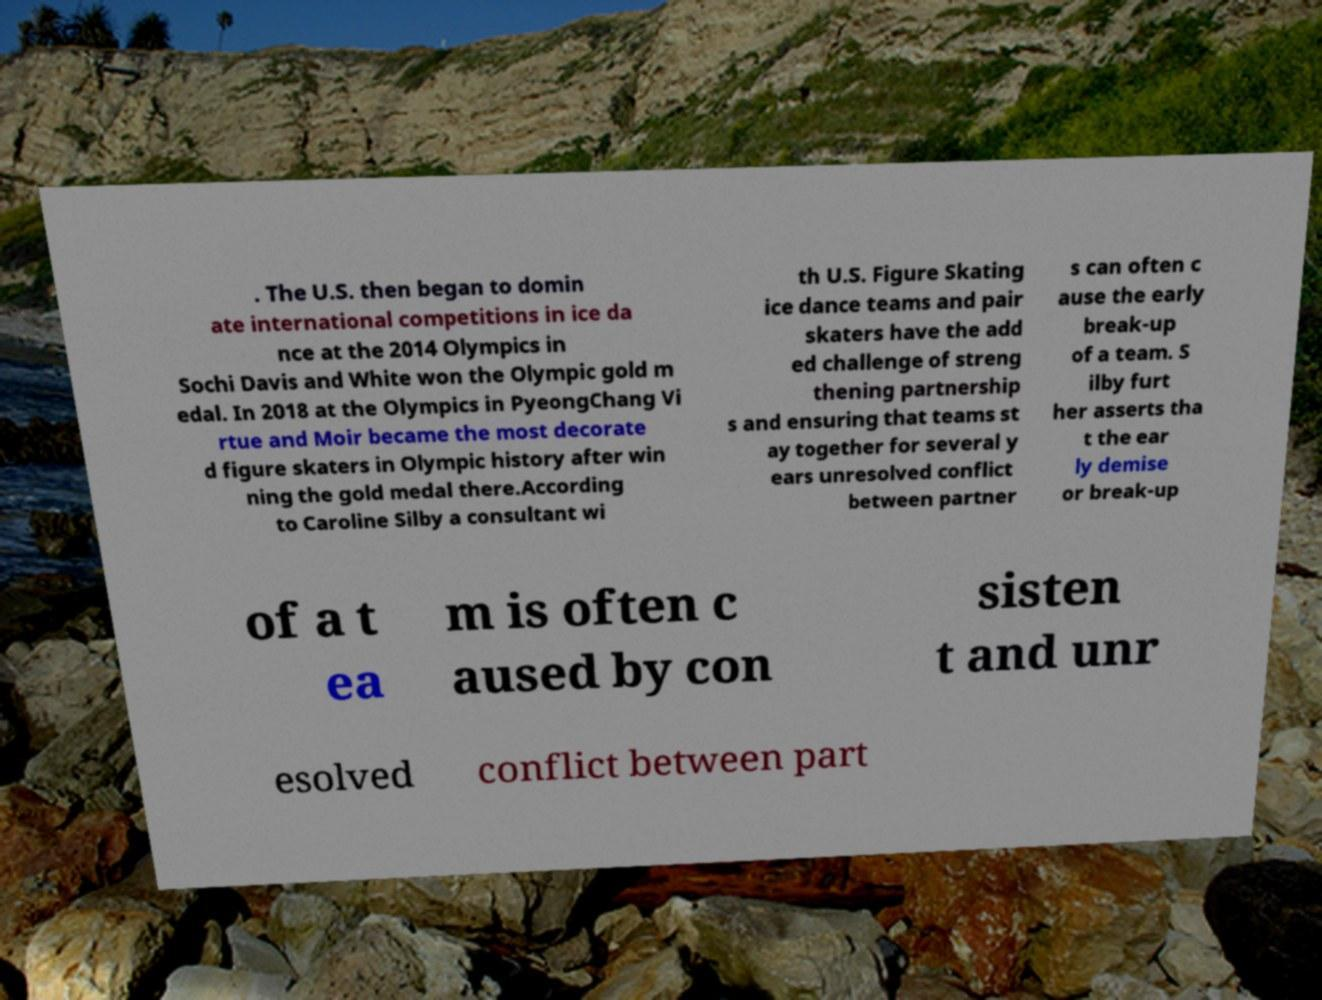Can you read and provide the text displayed in the image?This photo seems to have some interesting text. Can you extract and type it out for me? . The U.S. then began to domin ate international competitions in ice da nce at the 2014 Olympics in Sochi Davis and White won the Olympic gold m edal. In 2018 at the Olympics in PyeongChang Vi rtue and Moir became the most decorate d figure skaters in Olympic history after win ning the gold medal there.According to Caroline Silby a consultant wi th U.S. Figure Skating ice dance teams and pair skaters have the add ed challenge of streng thening partnership s and ensuring that teams st ay together for several y ears unresolved conflict between partner s can often c ause the early break-up of a team. S ilby furt her asserts tha t the ear ly demise or break-up of a t ea m is often c aused by con sisten t and unr esolved conflict between part 